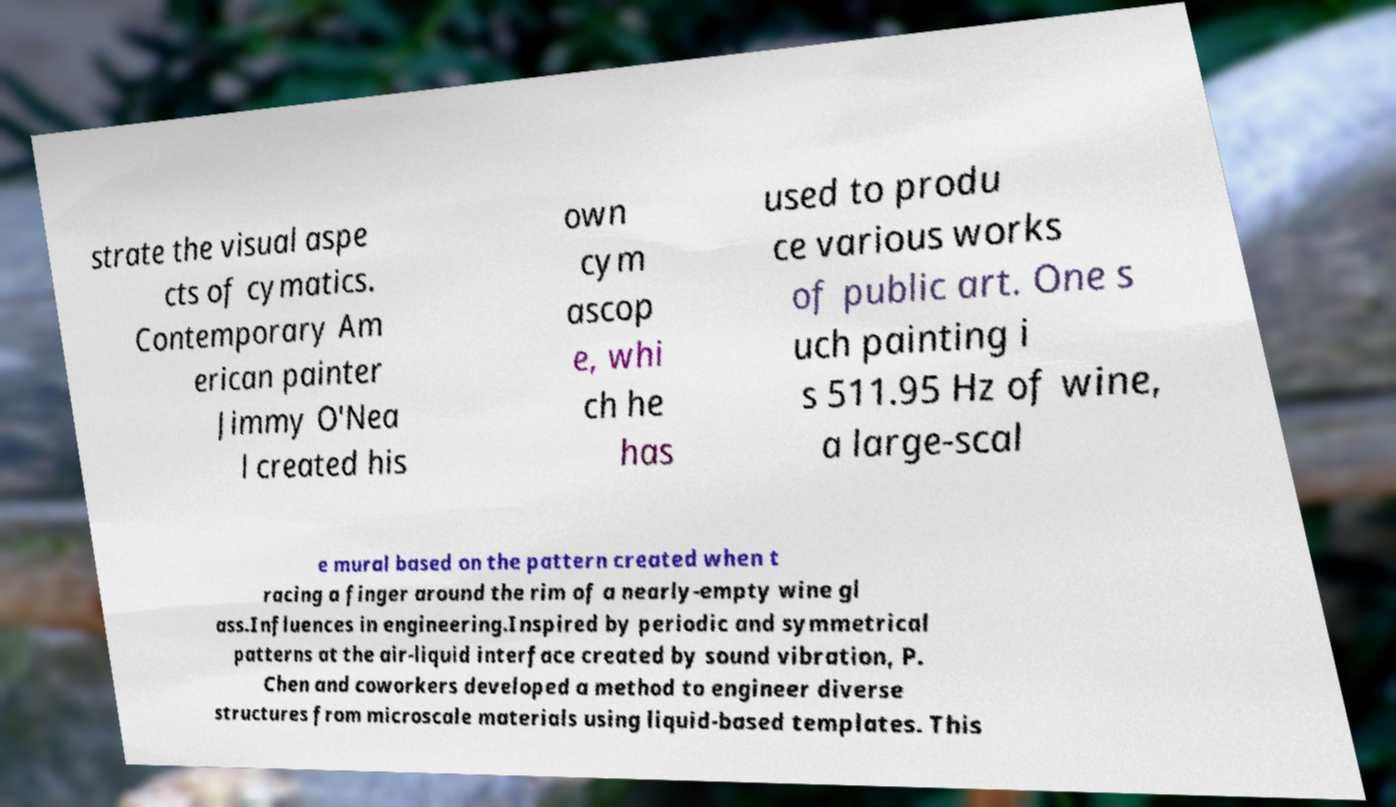There's text embedded in this image that I need extracted. Can you transcribe it verbatim? strate the visual aspe cts of cymatics. Contemporary Am erican painter Jimmy O'Nea l created his own cym ascop e, whi ch he has used to produ ce various works of public art. One s uch painting i s 511.95 Hz of wine, a large-scal e mural based on the pattern created when t racing a finger around the rim of a nearly-empty wine gl ass.Influences in engineering.Inspired by periodic and symmetrical patterns at the air-liquid interface created by sound vibration, P. Chen and coworkers developed a method to engineer diverse structures from microscale materials using liquid-based templates. This 